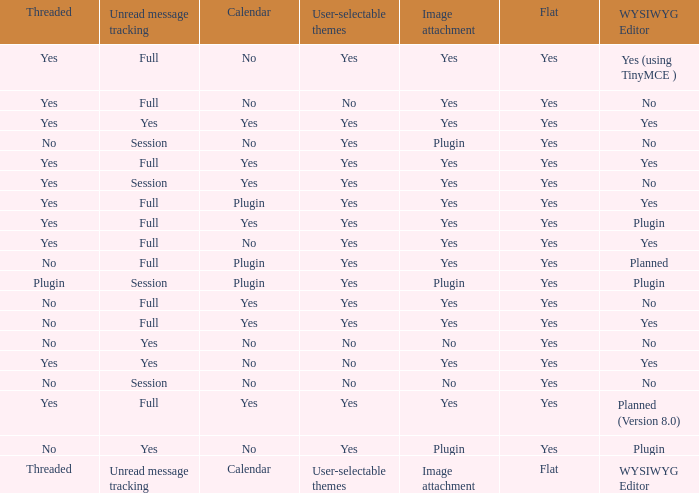Which WYSIWYG Editor has a User-selectable themes of yes, and an Unread message tracking of session, and an Image attachment of plugin? No, Plugin. 